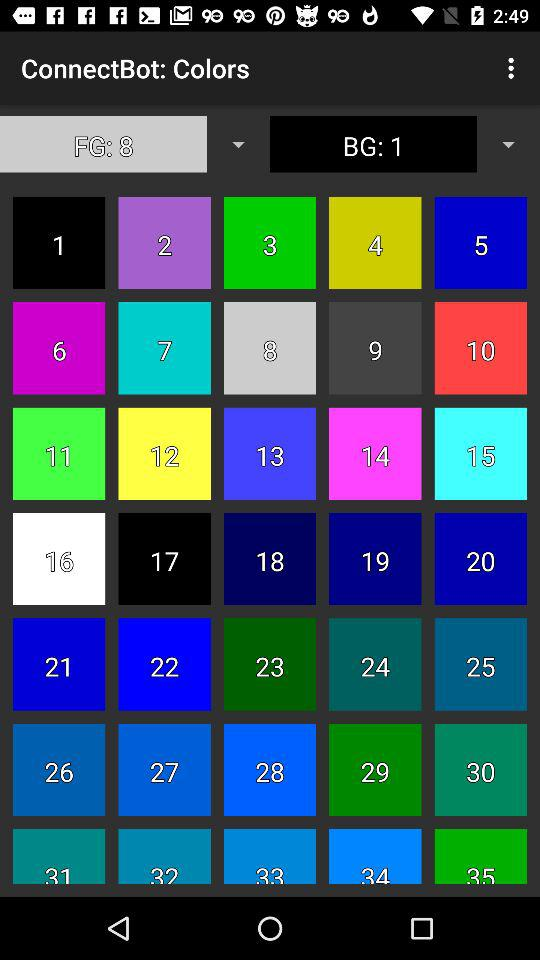Which color number is chosen as the foreground color? The chosen foreground color number is 8. 